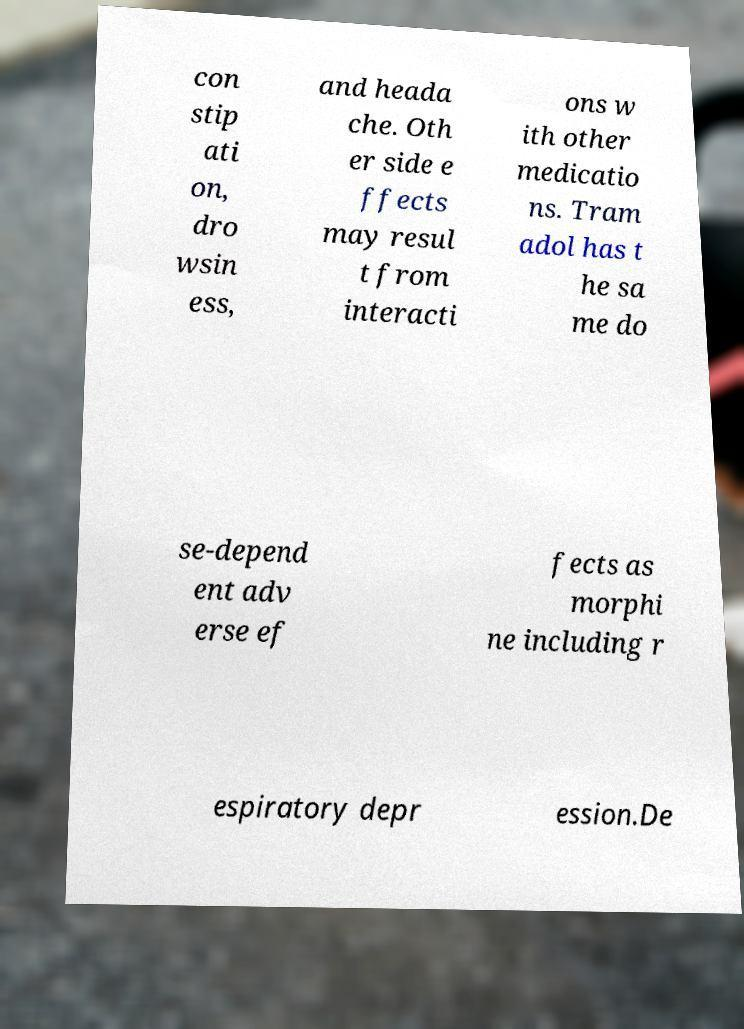Can you accurately transcribe the text from the provided image for me? con stip ati on, dro wsin ess, and heada che. Oth er side e ffects may resul t from interacti ons w ith other medicatio ns. Tram adol has t he sa me do se-depend ent adv erse ef fects as morphi ne including r espiratory depr ession.De 